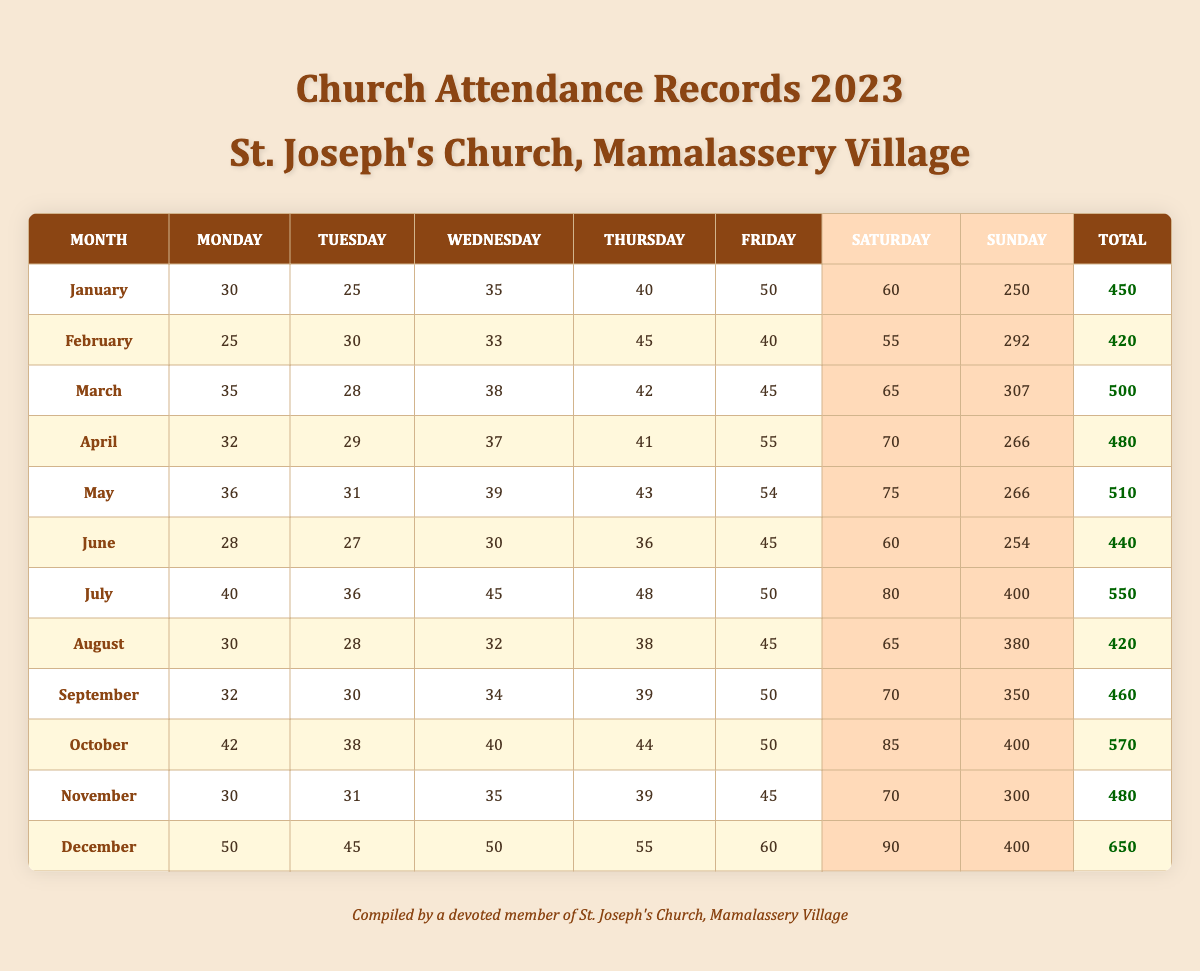What was the total attendance in March? According to the table, the total attendance for March is explicitly listed as 500.
Answer: 500 How many people attended St. Joseph's Church on Sundays in July? The table shows that Sunday attendance in July is 400.
Answer: 400 What was the average weekday attendance in February? The weekday attendance for February is: 25 (Mon) + 30 (Tue) + 33 (Wed) + 45 (Thu) + 40 (Fri) = 173. Dividing this by 5 gives an average of 34.6.
Answer: 34.6 Which month had the highest total attendance? By comparing the total attendances listed for each month, December has the highest total attendance of 650.
Answer: December Did the attendance increase from April to May? Comparing the total attendance, April has 480 and May has 510. Since 510 is more than 480, attendance did increase.
Answer: Yes What is the difference in total attendance between January and October? January's total attendance is 450, and October's is 570. The difference is 570 - 450 = 120.
Answer: 120 What was the average total attendance for the first half of the year (January to June)? The total attendances from January to June are: 450, 420, 500, 480, 510, 440. Summing these gives 450 + 420 + 500 + 480 + 510 + 440 = 2800. Dividing by 6 provides an average of approximately 466.7.
Answer: 466.7 Which weekday had the highest attendance in November? The weekday attendance for November is: 30 (Mon), 31 (Tue), 35 (Wed), 39 (Thu), 45 (Fri). The highest value is 45 on Friday.
Answer: Friday Was the total attendance for June less than that of August? June's total attendance is 440 and August's is 420. Since 440 is greater than 420, the total for June is not less than August.
Answer: No What was the total attendance for the weekends in April? The weekend attendance in April was 70 (Saturday) + 266 (Sunday) = 336.
Answer: 336 In which month did weekday attendance exceed 200 for the first time? Checking each month, May has a weekday total of 36 + 31 + 39 + 43 + 54 = 203, which exceeds 200 for the first time.
Answer: May 